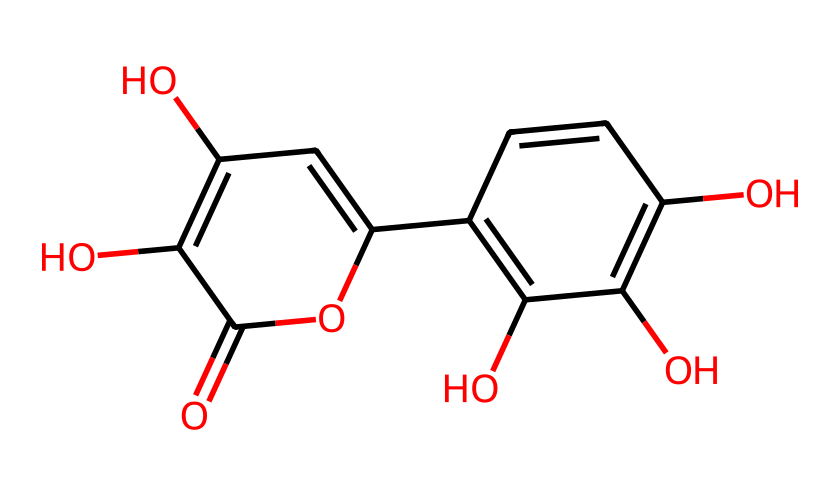How many hydroxyl (-OH) groups are present in this molecule? By examining the structural representation of the molecule, we can identify hydroxyl groups characterized by the presence of oxygen bonded to hydrogen atoms. In this chemical structure, there are five such hydroxyl groups based on their indications in the SMILES notation.
Answer: five What is the molecular formula of quercetin? To derive the molecular formula, we count the number of each type of atom present in the structure. Looking at the structure reveals 15 carbon atoms, 10 hydrogen atoms, and 7 oxygen atoms, leading to the formula C15H10O7.
Answer: C15H10O7 Which functional groups are present in this structure? By analyzing the molecule, we can identify the functional groups based on their typical arrangements. In addition to hydroxyl (-OH) groups, the presence of the carbonyl group (C=O) indicates that the molecule contains both phenolic and ketone functional characteristics. This is consistent with the structure of flavonoids.
Answer: hydroxyl and carbonyl groups How many rings are present in the quercetin structure? By inspecting the carbon backbones in the chemical structure, it becomes evident that the molecule forms two fused aromatic rings. This is typical of flavonoids, which often exhibit multiple ring structures.
Answer: two What type of antioxidant is quercetin classified as? When considering the active components of this molecule and their sources, quercetin is classified as a flavonoid antioxidant, known for its ability to neutralize free radicals and reduce oxidative stress.
Answer: flavonoid antioxidant 